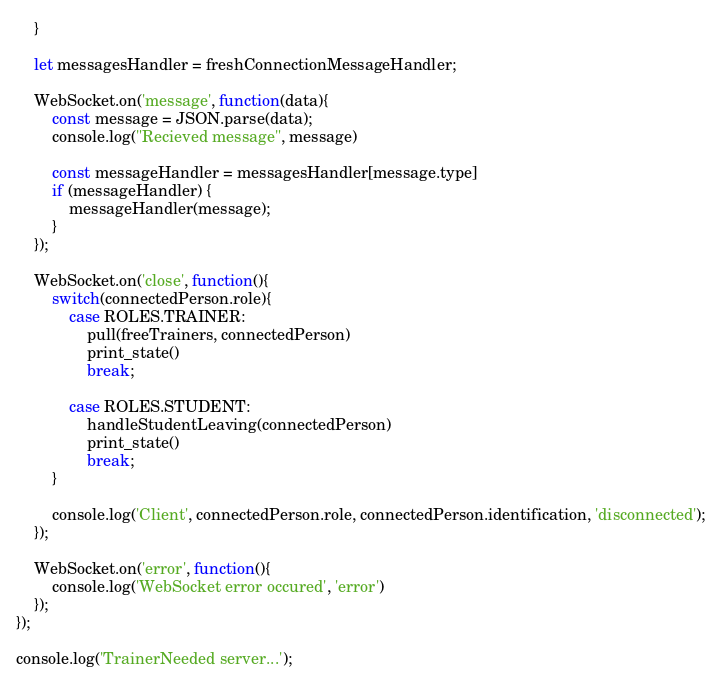Convert code to text. <code><loc_0><loc_0><loc_500><loc_500><_JavaScript_>    }

    let messagesHandler = freshConnectionMessageHandler;

    WebSocket.on('message', function(data){
        const message = JSON.parse(data);
        console.log("Recieved message", message)

        const messageHandler = messagesHandler[message.type]
        if (messageHandler) {
            messageHandler(message);
        }
    });

    WebSocket.on('close', function(){
        switch(connectedPerson.role){
            case ROLES.TRAINER:
                pull(freeTrainers, connectedPerson)
                print_state()
                break;
            
            case ROLES.STUDENT:
                handleStudentLeaving(connectedPerson)
                print_state()
                break;
        }
        
        console.log('Client', connectedPerson.role, connectedPerson.identification, 'disconnected');
    });

    WebSocket.on('error', function(){
        console.log('WebSocket error occured', 'error')
    });
});

console.log('TrainerNeeded server...');
</code> 